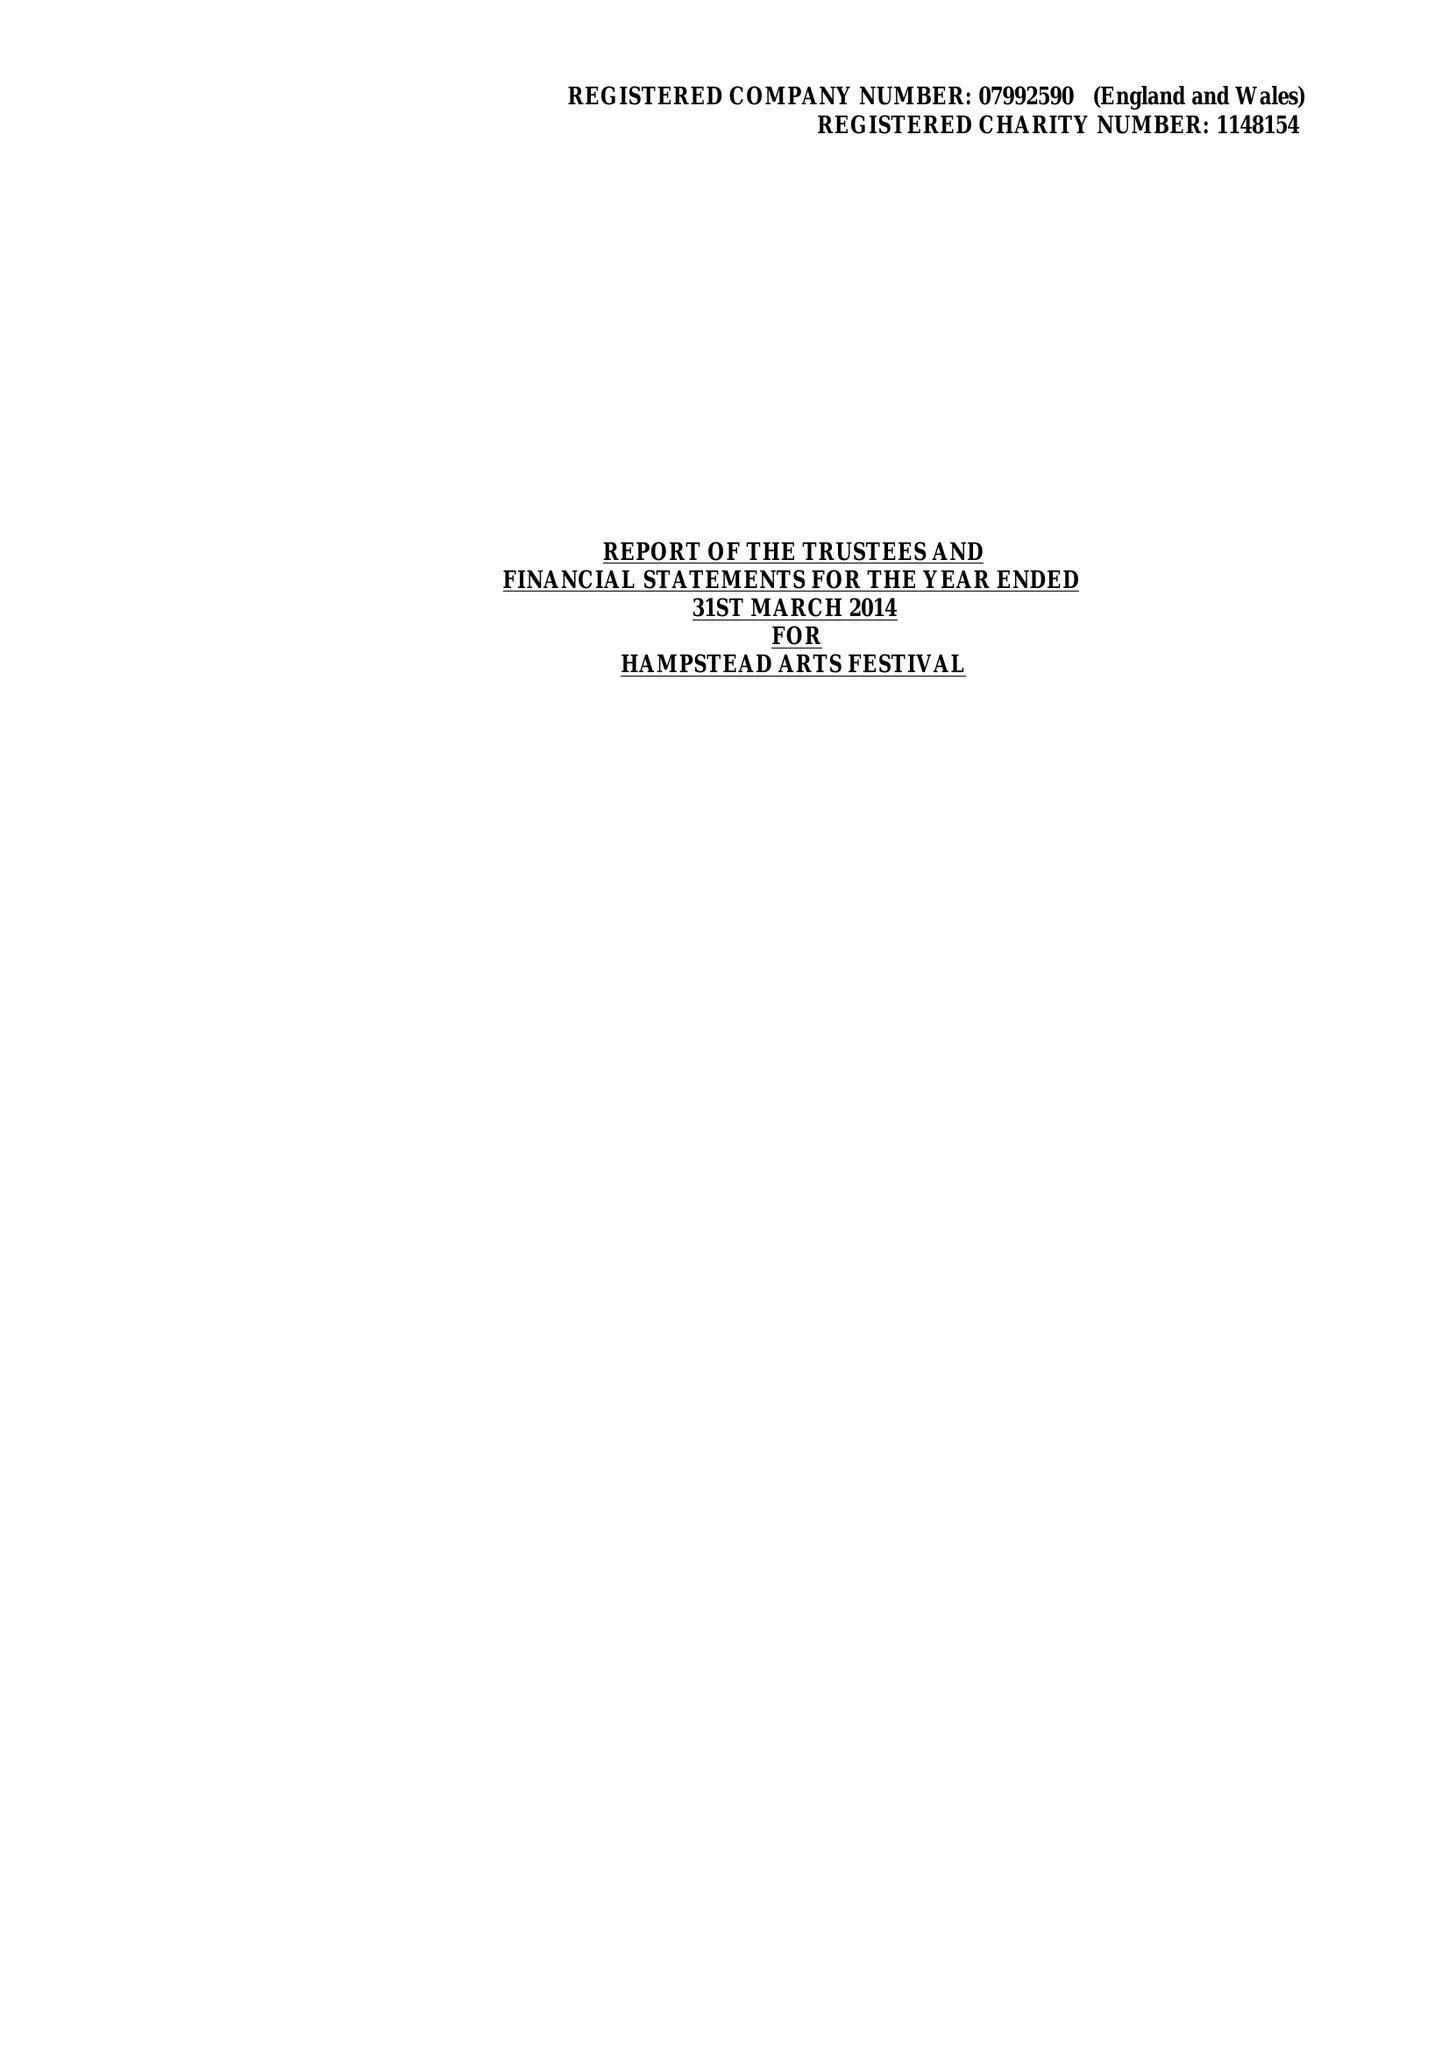What is the value for the address__postcode?
Answer the question using a single word or phrase. HA1 1EJ 